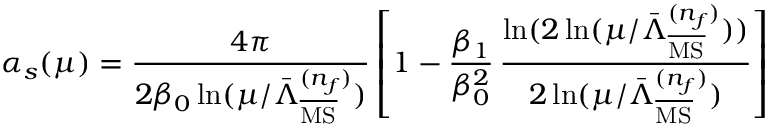Convert formula to latex. <formula><loc_0><loc_0><loc_500><loc_500>\alpha _ { s } ( \mu ) = \frac { 4 \pi } { 2 \beta _ { 0 } \ln ( \mu / \bar { \Lambda } _ { \overline { M S } } ^ { ( n _ { f } ) } ) } \left [ 1 - \frac { \beta _ { 1 } } { \beta _ { 0 } ^ { 2 } } \, \frac { \ln ( 2 \ln ( \mu / \bar { \Lambda } _ { \overline { M S } } ^ { ( n _ { f } ) } ) ) } { 2 \ln ( \mu / \bar { \Lambda } _ { \overline { M S } } ^ { ( n _ { f } ) } ) } \right ]</formula> 